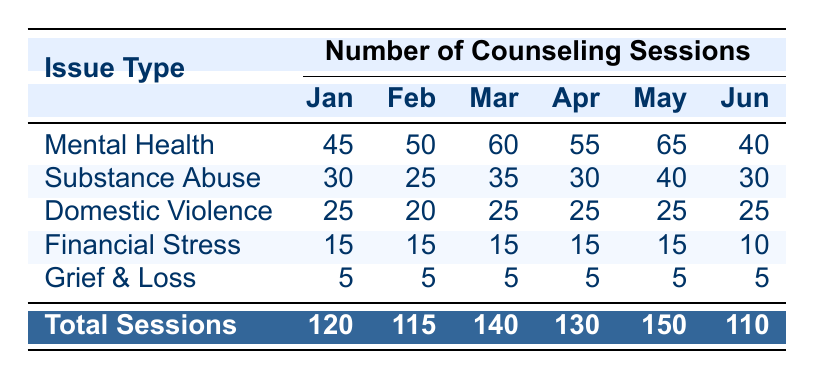What issue type had the highest number of counseling sessions in March 2023? In March 2023, the number of counseling sessions by issue type are: mental health (60), substance abuse (35), domestic violence (25), financial stress (15), and grief & loss (5). The highest count is for mental health at 60 sessions.
Answer: Mental health What is the total number of counseling sessions provided in April 2023? The total number of counseling sessions for April 2023 is directly listed in the table as 130.
Answer: 130 Which issue type had the least amount of counseling sessions across all months? Looking at the issue types, grief & loss consistently had 5 sessions every month from January to June, which is the lowest compared to other issue types in any month.
Answer: Grief & loss What was the average number of counseling sessions for substance abuse from January to June 2023? The number of sessions for substance abuse in each month is as follows: January (30), February (25), March (35), April (30), May (40), June (30). To find the average, sum these values (30 + 25 + 35 + 30 + 40 + 30 = 220) and divide by the number of months (6). This results in an average of 220 / 6 = 36.67.
Answer: 36.67 Did the total number of counseling sessions increase from January to May 2023? The total sessions in January were 120 and in May they were 150. This shows an increase of 30 sessions. Thus, the answer is yes.
Answer: Yes What is the percentage of counseling sessions related to mental health in May 2023 compared to total sessions that month? In May 2023, there were 65 mental health sessions out of a total of 150 sessions. To find the percentage, divide 65 by 150 and then multiply by 100, resulting in (65 / 150) * 100 = 43.33%.
Answer: 43.33% What was the trend of counseling sessions for financial stress from January to June 2023? The number of financial stress sessions remained constant at 15 sessions from January to April and then dropped to 10 in June. This indicates a declining trend towards the end of the period under review.
Answer: Declining trend How many more counseling sessions were dedicated to substance abuse than domestic violence in February 2023? In February 2023, substance abuse had 25 sessions and domestic violence had 20 sessions. To find the difference, subtract the domestic violence sessions from substance abuse sessions: 25 - 20 = 5.
Answer: 5 